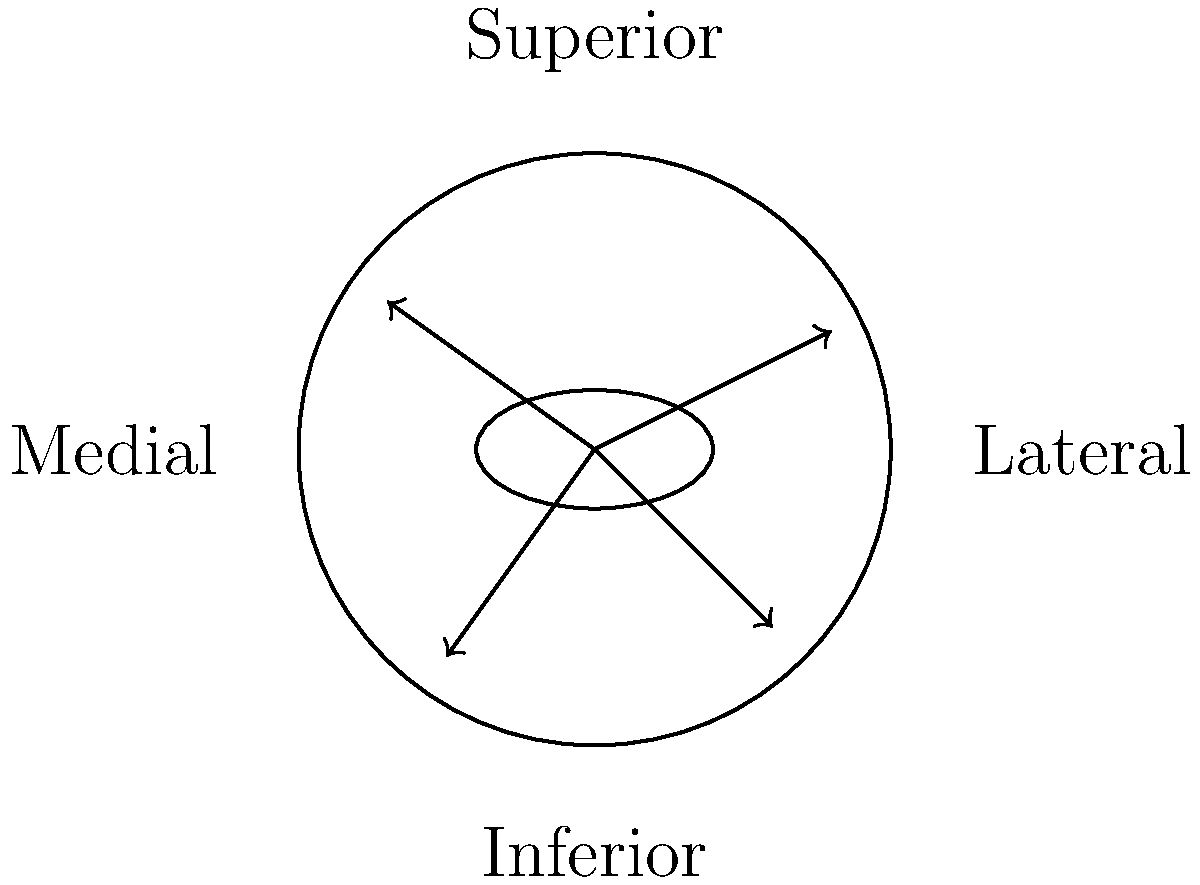During REM sleep, the eye movements are characterized by rapid, multi-directional saccades. Based on the diagram showing motion vectors of eye movement during REM sleep, which neurobiological mechanism is primarily responsible for generating these rapid eye movements, and how does this relate to the emotional processing occurring during this sleep stage? To answer this question, let's break it down step-by-step:

1. REM sleep eye movements:
   The diagram shows multiple vectors pointing in various directions, representing the rapid, multi-directional eye movements characteristic of REM sleep.

2. Neurobiological mechanism:
   The primary mechanism responsible for generating these rapid eye movements is the activation of the brainstem, specifically:
   a) The pontine reticular formation
   b) The vestibular nuclei
   c) The oculomotor nuclei

3. Pontine reticular formation:
   This region generates the signals that initiate the rapid eye movements. It becomes highly active during REM sleep.

4. Vestibular nuclei:
   These nuclei are involved in processing information about head position and movement. During REM sleep, they contribute to the generation of eye movements despite the absence of actual head movement.

5. Oculomotor nuclei:
   These nuclei control the extraocular muscles, executing the eye movements based on signals from the pontine reticular formation and vestibular nuclei.

6. Relationship to emotional processing:
   a) The rapid eye movements coincide with increased activity in the limbic system, particularly the amygdala, which is crucial for emotional processing.
   b) The pontine reticular formation has connections to the limbic system, potentially linking eye movements to emotional content in dreams.
   c) The activation of these brainstem regions during REM sleep is associated with increased cortical activity, particularly in areas involved in visual processing and emotional regulation.

7. Emotional significance:
   The coordination between eye movements and emotional processing during REM sleep is thought to play a role in:
   a) Emotional memory consolidation
   b) Processing of emotional experiences
   c) Regulation of mood and emotional reactivity

In summary, the rapid eye movements during REM sleep are primarily generated by brainstem mechanisms, which are closely linked to the activation of emotional processing centers in the brain. This neurobiological interplay contributes to the emotional aspects of dreaming and the potential emotional benefits of REM sleep.
Answer: Brainstem activation (pontine reticular formation, vestibular nuclei, oculomotor nuclei) generates rapid eye movements, coordinating with limbic system activity for emotional processing during REM sleep. 